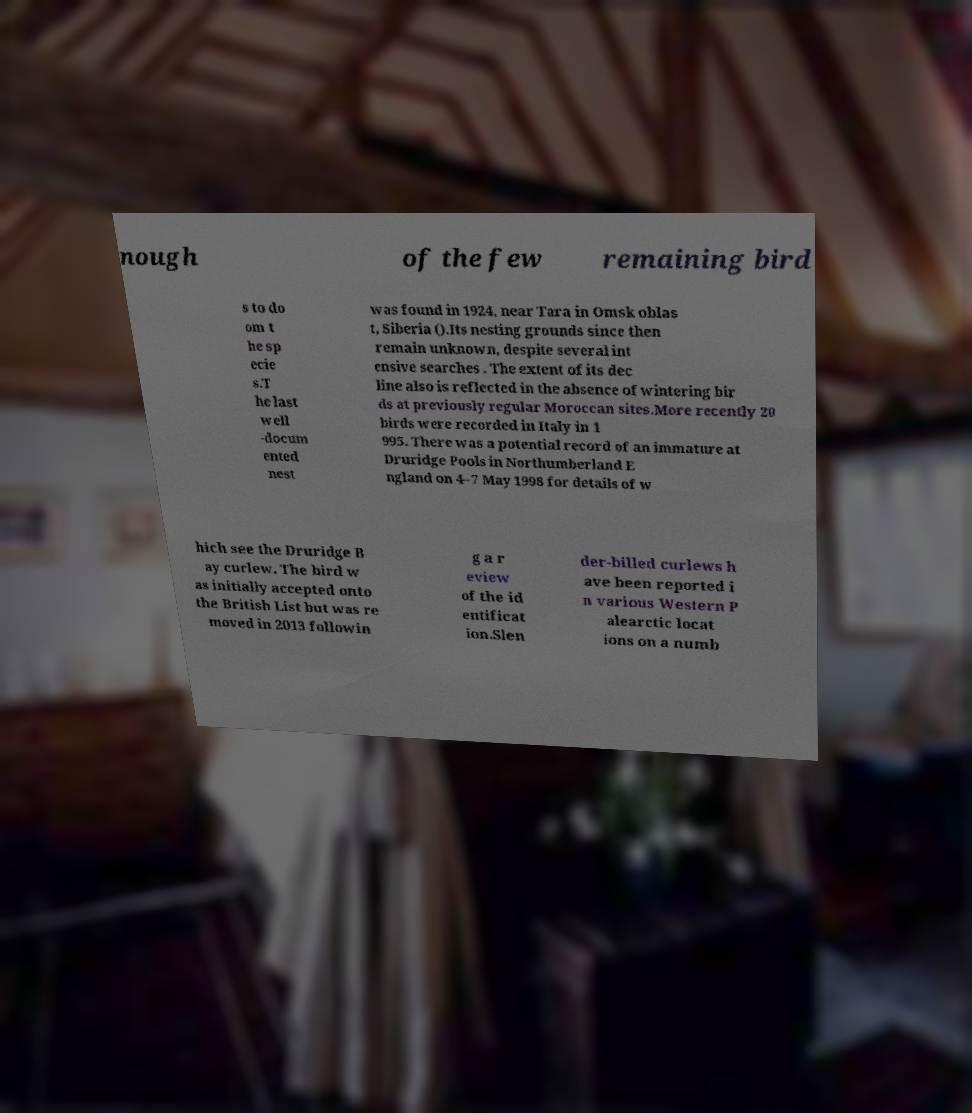Can you read and provide the text displayed in the image?This photo seems to have some interesting text. Can you extract and type it out for me? nough of the few remaining bird s to do om t he sp ecie s.T he last well -docum ented nest was found in 1924, near Tara in Omsk oblas t, Siberia ().Its nesting grounds since then remain unknown, despite several int ensive searches . The extent of its dec line also is reflected in the absence of wintering bir ds at previously regular Moroccan sites.More recently 20 birds were recorded in Italy in 1 995. There was a potential record of an immature at Druridge Pools in Northumberland E ngland on 4–7 May 1998 for details of w hich see the Druridge B ay curlew. The bird w as initially accepted onto the British List but was re moved in 2013 followin g a r eview of the id entificat ion.Slen der-billed curlews h ave been reported i n various Western P alearctic locat ions on a numb 